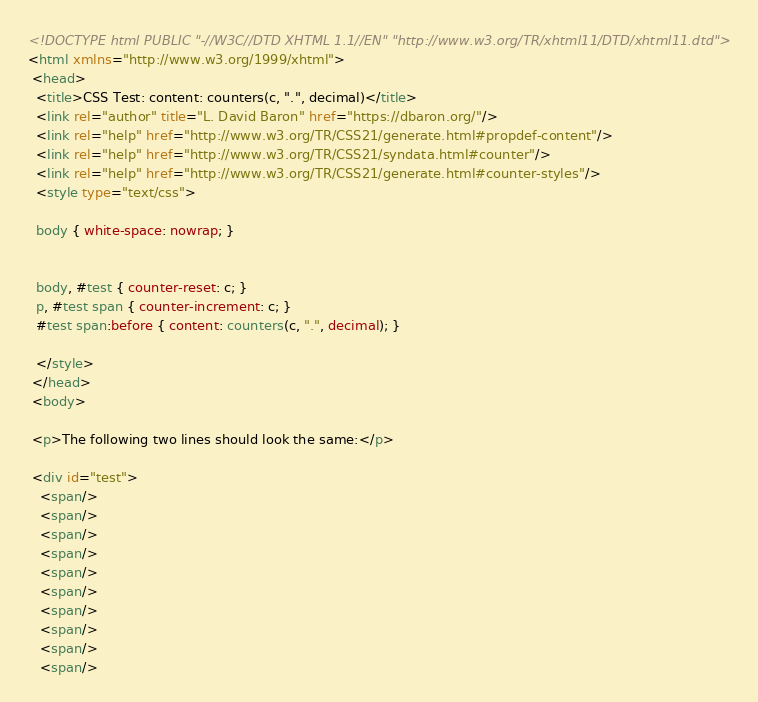<code> <loc_0><loc_0><loc_500><loc_500><_HTML_><!DOCTYPE html PUBLIC "-//W3C//DTD XHTML 1.1//EN" "http://www.w3.org/TR/xhtml11/DTD/xhtml11.dtd">
<html xmlns="http://www.w3.org/1999/xhtml">
 <head>
  <title>CSS Test: content: counters(c, ".", decimal)</title>
  <link rel="author" title="L. David Baron" href="https://dbaron.org/"/>
  <link rel="help" href="http://www.w3.org/TR/CSS21/generate.html#propdef-content"/>
  <link rel="help" href="http://www.w3.org/TR/CSS21/syndata.html#counter"/>
  <link rel="help" href="http://www.w3.org/TR/CSS21/generate.html#counter-styles"/>
  <style type="text/css">

  body { white-space: nowrap; }


  body, #test { counter-reset: c; }
  p, #test span { counter-increment: c; }
  #test span:before { content: counters(c, ".", decimal); }

  </style>
 </head>
 <body>

 <p>The following two lines should look the same:</p>

 <div id="test">
   <span/>
   <span/>
   <span/>
   <span/>
   <span/>
   <span/>
   <span/>
   <span/>
   <span/>
   <span/></code> 